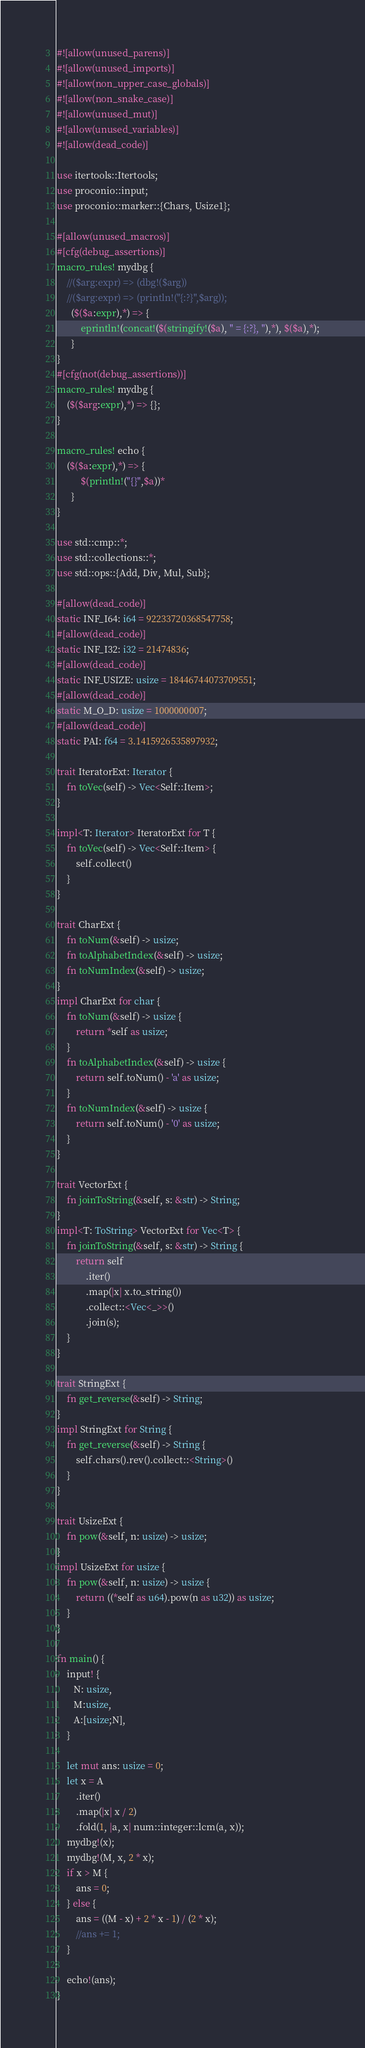<code> <loc_0><loc_0><loc_500><loc_500><_Rust_>#![allow(unused_parens)]
#![allow(unused_imports)]
#![allow(non_upper_case_globals)]
#![allow(non_snake_case)]
#![allow(unused_mut)]
#![allow(unused_variables)]
#![allow(dead_code)]

use itertools::Itertools;
use proconio::input;
use proconio::marker::{Chars, Usize1};

#[allow(unused_macros)]
#[cfg(debug_assertions)]
macro_rules! mydbg {
    //($arg:expr) => (dbg!($arg))
    //($arg:expr) => (println!("{:?}",$arg));
      ($($a:expr),*) => {
          eprintln!(concat!($(stringify!($a), " = {:?}, "),*), $($a),*);
      }
}
#[cfg(not(debug_assertions))]
macro_rules! mydbg {
    ($($arg:expr),*) => {};
}

macro_rules! echo {
    ($($a:expr),*) => {
          $(println!("{}",$a))*
      }
}

use std::cmp::*;
use std::collections::*;
use std::ops::{Add, Div, Mul, Sub};

#[allow(dead_code)]
static INF_I64: i64 = 92233720368547758;
#[allow(dead_code)]
static INF_I32: i32 = 21474836;
#[allow(dead_code)]
static INF_USIZE: usize = 18446744073709551;
#[allow(dead_code)]
static M_O_D: usize = 1000000007;
#[allow(dead_code)]
static PAI: f64 = 3.1415926535897932;

trait IteratorExt: Iterator {
    fn toVec(self) -> Vec<Self::Item>;
}

impl<T: Iterator> IteratorExt for T {
    fn toVec(self) -> Vec<Self::Item> {
        self.collect()
    }
}

trait CharExt {
    fn toNum(&self) -> usize;
    fn toAlphabetIndex(&self) -> usize;
    fn toNumIndex(&self) -> usize;
}
impl CharExt for char {
    fn toNum(&self) -> usize {
        return *self as usize;
    }
    fn toAlphabetIndex(&self) -> usize {
        return self.toNum() - 'a' as usize;
    }
    fn toNumIndex(&self) -> usize {
        return self.toNum() - '0' as usize;
    }
}

trait VectorExt {
    fn joinToString(&self, s: &str) -> String;
}
impl<T: ToString> VectorExt for Vec<T> {
    fn joinToString(&self, s: &str) -> String {
        return self
            .iter()
            .map(|x| x.to_string())
            .collect::<Vec<_>>()
            .join(s);
    }
}

trait StringExt {
    fn get_reverse(&self) -> String;
}
impl StringExt for String {
    fn get_reverse(&self) -> String {
        self.chars().rev().collect::<String>()
    }
}

trait UsizeExt {
    fn pow(&self, n: usize) -> usize;
}
impl UsizeExt for usize {
    fn pow(&self, n: usize) -> usize {
        return ((*self as u64).pow(n as u32)) as usize;
    }
}

fn main() {
    input! {
       N: usize,
       M:usize,
       A:[usize;N],
    }

    let mut ans: usize = 0;
    let x = A
        .iter()
        .map(|x| x / 2)
        .fold(1, |a, x| num::integer::lcm(a, x));
    mydbg!(x);
    mydbg!(M, x, 2 * x);
    if x > M {
        ans = 0;
    } else {
        ans = ((M - x) + 2 * x - 1) / (2 * x);
        //ans += 1;
    }

    echo!(ans);
}
</code> 